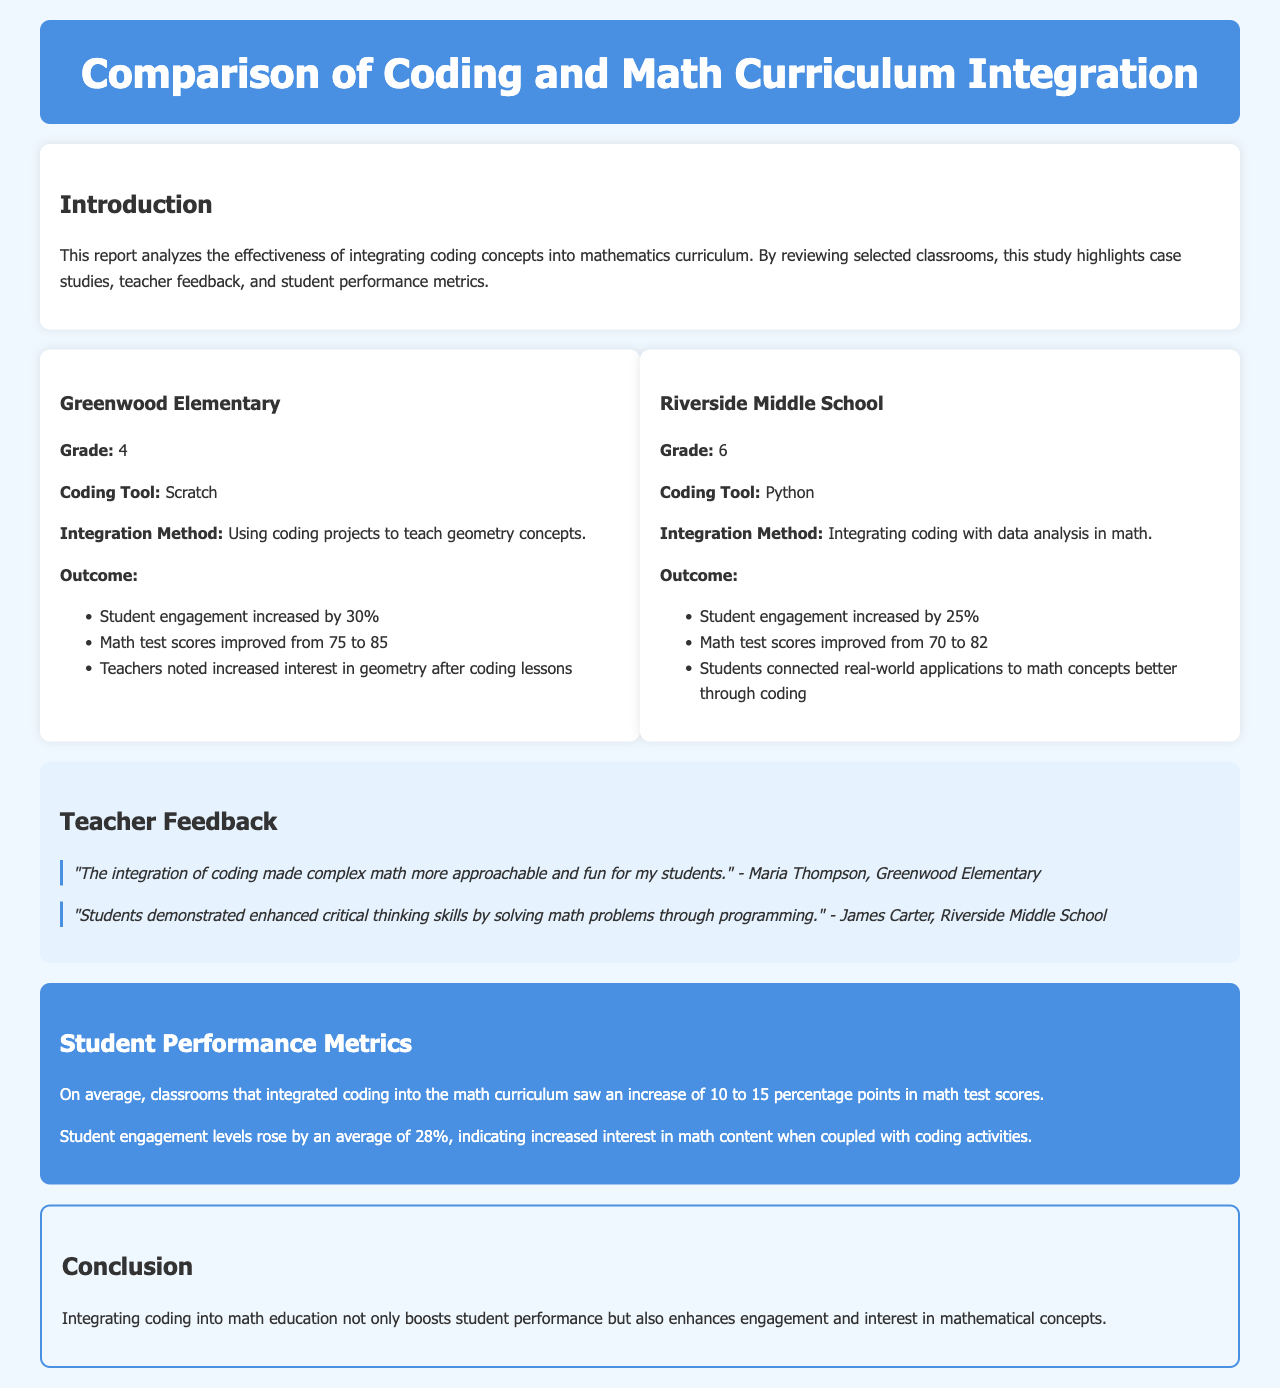What is the title of the report? The title, as indicated in the header, summarizes the main subject of the content analyzed in the document.
Answer: Comparison of Coding and Math Curriculum Integration What was the coding tool used at Greenwood Elementary? This information is specified within the case study section highlighting a particular school's integration method and tools.
Answer: Scratch How much did student engagement increase at Riverside Middle School? The report details the outcomes of the integration efforts, including specific engagement metrics captured in the case studies.
Answer: 25% What grade did Maria Thompson teach? The teacher's feedback located in the document mentions her experience and provides context on the curriculum integration.
Answer: 4 By how many percentage points did math test scores improve at Greenwood Elementary? The document lists specific performance metrics that quantify the impact of coding integration on student test scores.
Answer: 10 What average increase in student engagement levels was noted across classrooms? This average increase is mentioned in the metrics section, indicating overall trends observed in the integration of coding into math education.
Answer: 28% Which subject showed increased interest after coding lessons according to teacher feedback? The statement is derived from teacher testimonials that express their observations regarding student reactions to the integrated lessons.
Answer: Geometry What is one outcome mentioned for Riverside Middle School students? This inquiry looks for a specific result from the listed outcomes that demonstrate the effectiveness of the curriculum integration.
Answer: Connected real-world applications to math concepts better through coding 